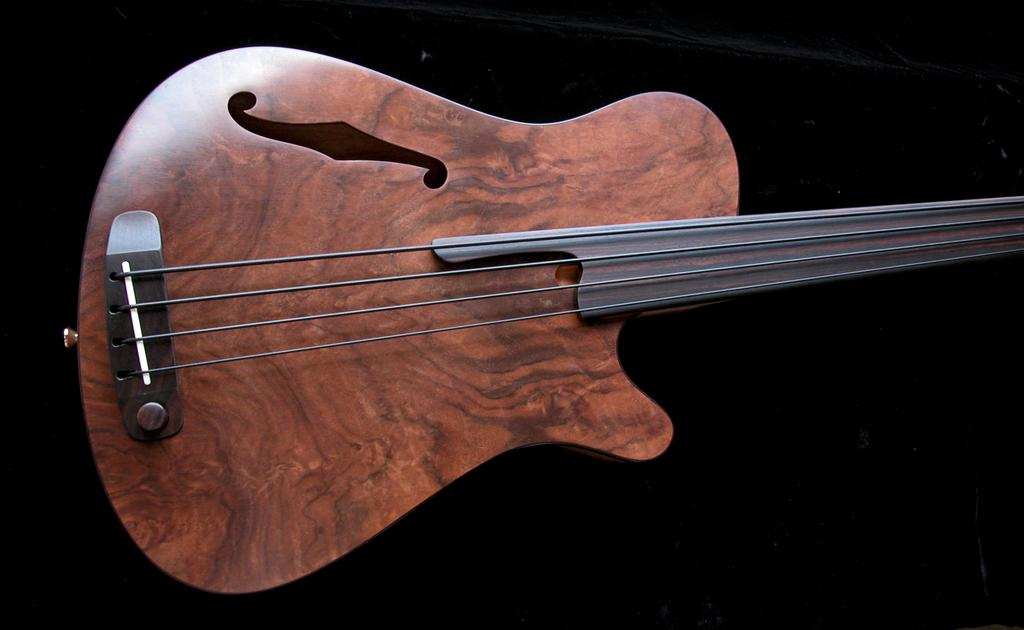What musical instrument is placed in the image? There is a guitar placed in the image. What type of haircut does the guitar have in the image? The guitar does not have a haircut, as it is an inanimate object and cannot have a haircut. 